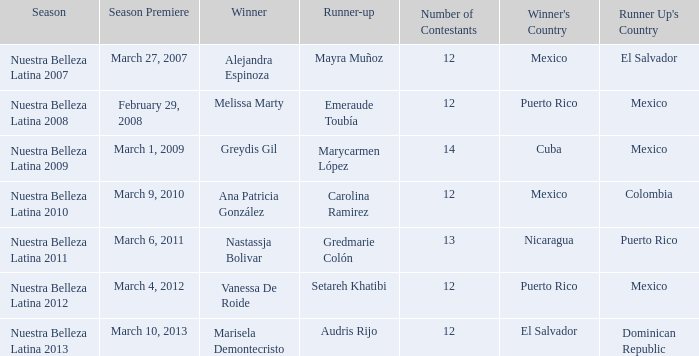What season's commencement saw puerto rico's win on may 20, 2012? March 4, 2012. Parse the table in full. {'header': ['Season', 'Season Premiere', 'Winner', 'Runner-up', 'Number of Contestants', "Winner's Country", "Runner Up's Country"], 'rows': [['Nuestra Belleza Latina 2007', 'March 27, 2007', 'Alejandra Espinoza', 'Mayra Muñoz', '12', 'Mexico', 'El Salvador'], ['Nuestra Belleza Latina 2008', 'February 29, 2008', 'Melissa Marty', 'Emeraude Toubía', '12', 'Puerto Rico', 'Mexico'], ['Nuestra Belleza Latina 2009', 'March 1, 2009', 'Greydis Gil', 'Marycarmen López', '14', 'Cuba', 'Mexico'], ['Nuestra Belleza Latina 2010', 'March 9, 2010', 'Ana Patricia González', 'Carolina Ramirez', '12', 'Mexico', 'Colombia'], ['Nuestra Belleza Latina 2011', 'March 6, 2011', 'Nastassja Bolivar', 'Gredmarie Colón', '13', 'Nicaragua', 'Puerto Rico'], ['Nuestra Belleza Latina 2012', 'March 4, 2012', 'Vanessa De Roide', 'Setareh Khatibi', '12', 'Puerto Rico', 'Mexico'], ['Nuestra Belleza Latina 2013', 'March 10, 2013', 'Marisela Demontecristo', 'Audris Rijo', '12', 'El Salvador', 'Dominican Republic']]} 